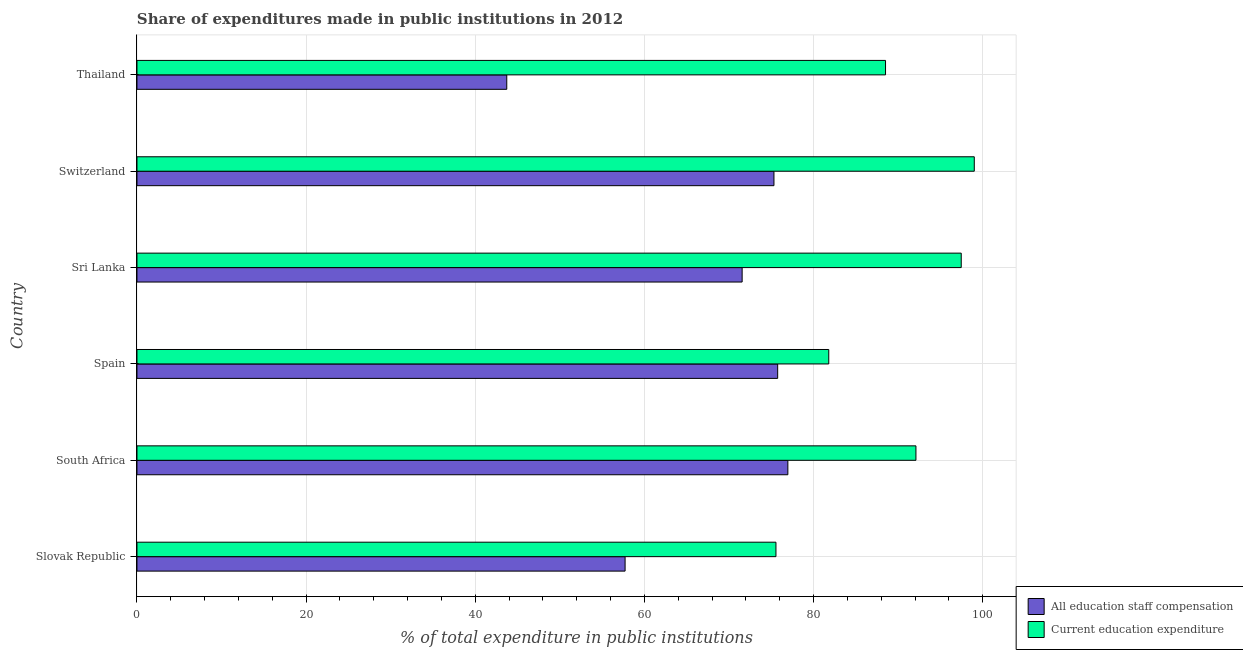How many different coloured bars are there?
Make the answer very short. 2. How many groups of bars are there?
Your answer should be compact. 6. Are the number of bars on each tick of the Y-axis equal?
Offer a very short reply. Yes. How many bars are there on the 1st tick from the bottom?
Give a very brief answer. 2. What is the label of the 6th group of bars from the top?
Give a very brief answer. Slovak Republic. What is the expenditure in staff compensation in South Africa?
Make the answer very short. 76.97. Across all countries, what is the maximum expenditure in staff compensation?
Keep it short and to the point. 76.97. Across all countries, what is the minimum expenditure in education?
Provide a succinct answer. 75.56. In which country was the expenditure in staff compensation maximum?
Give a very brief answer. South Africa. In which country was the expenditure in staff compensation minimum?
Your answer should be very brief. Thailand. What is the total expenditure in education in the graph?
Make the answer very short. 534.46. What is the difference between the expenditure in staff compensation in Slovak Republic and that in South Africa?
Make the answer very short. -19.25. What is the difference between the expenditure in staff compensation in Slovak Republic and the expenditure in education in South Africa?
Give a very brief answer. -34.39. What is the average expenditure in staff compensation per country?
Offer a very short reply. 66.84. What is the difference between the expenditure in education and expenditure in staff compensation in Slovak Republic?
Your answer should be compact. 17.84. What is the ratio of the expenditure in staff compensation in Slovak Republic to that in South Africa?
Your answer should be very brief. 0.75. What is the difference between the highest and the second highest expenditure in education?
Keep it short and to the point. 1.54. What is the difference between the highest and the lowest expenditure in education?
Your answer should be very brief. 23.45. In how many countries, is the expenditure in education greater than the average expenditure in education taken over all countries?
Your answer should be compact. 3. What does the 2nd bar from the top in Slovak Republic represents?
Provide a short and direct response. All education staff compensation. What does the 2nd bar from the bottom in Thailand represents?
Your answer should be very brief. Current education expenditure. How many bars are there?
Offer a terse response. 12. Are all the bars in the graph horizontal?
Provide a short and direct response. Yes. Does the graph contain grids?
Your response must be concise. Yes. Where does the legend appear in the graph?
Offer a terse response. Bottom right. How many legend labels are there?
Your answer should be compact. 2. How are the legend labels stacked?
Your answer should be very brief. Vertical. What is the title of the graph?
Your answer should be very brief. Share of expenditures made in public institutions in 2012. Does "By country of origin" appear as one of the legend labels in the graph?
Keep it short and to the point. No. What is the label or title of the X-axis?
Ensure brevity in your answer.  % of total expenditure in public institutions. What is the % of total expenditure in public institutions of All education staff compensation in Slovak Republic?
Ensure brevity in your answer.  57.72. What is the % of total expenditure in public institutions in Current education expenditure in Slovak Republic?
Offer a terse response. 75.56. What is the % of total expenditure in public institutions of All education staff compensation in South Africa?
Provide a short and direct response. 76.97. What is the % of total expenditure in public institutions in Current education expenditure in South Africa?
Make the answer very short. 92.11. What is the % of total expenditure in public institutions of All education staff compensation in Spain?
Offer a very short reply. 75.76. What is the % of total expenditure in public institutions in Current education expenditure in Spain?
Give a very brief answer. 81.8. What is the % of total expenditure in public institutions in All education staff compensation in Sri Lanka?
Provide a short and direct response. 71.56. What is the % of total expenditure in public institutions in Current education expenditure in Sri Lanka?
Offer a terse response. 97.47. What is the % of total expenditure in public institutions in All education staff compensation in Switzerland?
Offer a very short reply. 75.32. What is the % of total expenditure in public institutions of Current education expenditure in Switzerland?
Ensure brevity in your answer.  99.01. What is the % of total expenditure in public institutions in All education staff compensation in Thailand?
Make the answer very short. 43.73. What is the % of total expenditure in public institutions in Current education expenditure in Thailand?
Provide a succinct answer. 88.51. Across all countries, what is the maximum % of total expenditure in public institutions in All education staff compensation?
Keep it short and to the point. 76.97. Across all countries, what is the maximum % of total expenditure in public institutions in Current education expenditure?
Your answer should be compact. 99.01. Across all countries, what is the minimum % of total expenditure in public institutions in All education staff compensation?
Offer a very short reply. 43.73. Across all countries, what is the minimum % of total expenditure in public institutions of Current education expenditure?
Offer a very short reply. 75.56. What is the total % of total expenditure in public institutions in All education staff compensation in the graph?
Provide a short and direct response. 401.06. What is the total % of total expenditure in public institutions of Current education expenditure in the graph?
Your answer should be very brief. 534.46. What is the difference between the % of total expenditure in public institutions of All education staff compensation in Slovak Republic and that in South Africa?
Your answer should be compact. -19.25. What is the difference between the % of total expenditure in public institutions in Current education expenditure in Slovak Republic and that in South Africa?
Give a very brief answer. -16.55. What is the difference between the % of total expenditure in public institutions in All education staff compensation in Slovak Republic and that in Spain?
Give a very brief answer. -18.04. What is the difference between the % of total expenditure in public institutions of Current education expenditure in Slovak Republic and that in Spain?
Ensure brevity in your answer.  -6.24. What is the difference between the % of total expenditure in public institutions in All education staff compensation in Slovak Republic and that in Sri Lanka?
Provide a succinct answer. -13.84. What is the difference between the % of total expenditure in public institutions in Current education expenditure in Slovak Republic and that in Sri Lanka?
Your response must be concise. -21.91. What is the difference between the % of total expenditure in public institutions in All education staff compensation in Slovak Republic and that in Switzerland?
Offer a terse response. -17.6. What is the difference between the % of total expenditure in public institutions in Current education expenditure in Slovak Republic and that in Switzerland?
Your response must be concise. -23.45. What is the difference between the % of total expenditure in public institutions in All education staff compensation in Slovak Republic and that in Thailand?
Keep it short and to the point. 13.99. What is the difference between the % of total expenditure in public institutions in Current education expenditure in Slovak Republic and that in Thailand?
Give a very brief answer. -12.96. What is the difference between the % of total expenditure in public institutions of All education staff compensation in South Africa and that in Spain?
Provide a succinct answer. 1.21. What is the difference between the % of total expenditure in public institutions in Current education expenditure in South Africa and that in Spain?
Make the answer very short. 10.31. What is the difference between the % of total expenditure in public institutions of All education staff compensation in South Africa and that in Sri Lanka?
Provide a short and direct response. 5.41. What is the difference between the % of total expenditure in public institutions in Current education expenditure in South Africa and that in Sri Lanka?
Make the answer very short. -5.36. What is the difference between the % of total expenditure in public institutions in All education staff compensation in South Africa and that in Switzerland?
Your answer should be compact. 1.64. What is the difference between the % of total expenditure in public institutions of Current education expenditure in South Africa and that in Switzerland?
Keep it short and to the point. -6.9. What is the difference between the % of total expenditure in public institutions in All education staff compensation in South Africa and that in Thailand?
Ensure brevity in your answer.  33.24. What is the difference between the % of total expenditure in public institutions of Current education expenditure in South Africa and that in Thailand?
Offer a terse response. 3.6. What is the difference between the % of total expenditure in public institutions in All education staff compensation in Spain and that in Sri Lanka?
Provide a short and direct response. 4.2. What is the difference between the % of total expenditure in public institutions of Current education expenditure in Spain and that in Sri Lanka?
Offer a terse response. -15.66. What is the difference between the % of total expenditure in public institutions of All education staff compensation in Spain and that in Switzerland?
Offer a terse response. 0.44. What is the difference between the % of total expenditure in public institutions of Current education expenditure in Spain and that in Switzerland?
Offer a very short reply. -17.21. What is the difference between the % of total expenditure in public institutions in All education staff compensation in Spain and that in Thailand?
Offer a very short reply. 32.03. What is the difference between the % of total expenditure in public institutions of Current education expenditure in Spain and that in Thailand?
Provide a succinct answer. -6.71. What is the difference between the % of total expenditure in public institutions in All education staff compensation in Sri Lanka and that in Switzerland?
Provide a succinct answer. -3.76. What is the difference between the % of total expenditure in public institutions of Current education expenditure in Sri Lanka and that in Switzerland?
Make the answer very short. -1.54. What is the difference between the % of total expenditure in public institutions of All education staff compensation in Sri Lanka and that in Thailand?
Keep it short and to the point. 27.83. What is the difference between the % of total expenditure in public institutions in Current education expenditure in Sri Lanka and that in Thailand?
Make the answer very short. 8.95. What is the difference between the % of total expenditure in public institutions in All education staff compensation in Switzerland and that in Thailand?
Your answer should be very brief. 31.6. What is the difference between the % of total expenditure in public institutions of Current education expenditure in Switzerland and that in Thailand?
Provide a short and direct response. 10.5. What is the difference between the % of total expenditure in public institutions of All education staff compensation in Slovak Republic and the % of total expenditure in public institutions of Current education expenditure in South Africa?
Ensure brevity in your answer.  -34.39. What is the difference between the % of total expenditure in public institutions in All education staff compensation in Slovak Republic and the % of total expenditure in public institutions in Current education expenditure in Spain?
Your response must be concise. -24.08. What is the difference between the % of total expenditure in public institutions of All education staff compensation in Slovak Republic and the % of total expenditure in public institutions of Current education expenditure in Sri Lanka?
Provide a succinct answer. -39.75. What is the difference between the % of total expenditure in public institutions in All education staff compensation in Slovak Republic and the % of total expenditure in public institutions in Current education expenditure in Switzerland?
Provide a short and direct response. -41.29. What is the difference between the % of total expenditure in public institutions of All education staff compensation in Slovak Republic and the % of total expenditure in public institutions of Current education expenditure in Thailand?
Provide a succinct answer. -30.79. What is the difference between the % of total expenditure in public institutions of All education staff compensation in South Africa and the % of total expenditure in public institutions of Current education expenditure in Spain?
Make the answer very short. -4.84. What is the difference between the % of total expenditure in public institutions in All education staff compensation in South Africa and the % of total expenditure in public institutions in Current education expenditure in Sri Lanka?
Your response must be concise. -20.5. What is the difference between the % of total expenditure in public institutions in All education staff compensation in South Africa and the % of total expenditure in public institutions in Current education expenditure in Switzerland?
Make the answer very short. -22.04. What is the difference between the % of total expenditure in public institutions in All education staff compensation in South Africa and the % of total expenditure in public institutions in Current education expenditure in Thailand?
Provide a succinct answer. -11.55. What is the difference between the % of total expenditure in public institutions in All education staff compensation in Spain and the % of total expenditure in public institutions in Current education expenditure in Sri Lanka?
Your answer should be very brief. -21.71. What is the difference between the % of total expenditure in public institutions in All education staff compensation in Spain and the % of total expenditure in public institutions in Current education expenditure in Switzerland?
Your response must be concise. -23.25. What is the difference between the % of total expenditure in public institutions in All education staff compensation in Spain and the % of total expenditure in public institutions in Current education expenditure in Thailand?
Give a very brief answer. -12.75. What is the difference between the % of total expenditure in public institutions of All education staff compensation in Sri Lanka and the % of total expenditure in public institutions of Current education expenditure in Switzerland?
Provide a short and direct response. -27.45. What is the difference between the % of total expenditure in public institutions of All education staff compensation in Sri Lanka and the % of total expenditure in public institutions of Current education expenditure in Thailand?
Offer a terse response. -16.95. What is the difference between the % of total expenditure in public institutions in All education staff compensation in Switzerland and the % of total expenditure in public institutions in Current education expenditure in Thailand?
Give a very brief answer. -13.19. What is the average % of total expenditure in public institutions in All education staff compensation per country?
Your answer should be very brief. 66.84. What is the average % of total expenditure in public institutions in Current education expenditure per country?
Make the answer very short. 89.08. What is the difference between the % of total expenditure in public institutions of All education staff compensation and % of total expenditure in public institutions of Current education expenditure in Slovak Republic?
Give a very brief answer. -17.84. What is the difference between the % of total expenditure in public institutions in All education staff compensation and % of total expenditure in public institutions in Current education expenditure in South Africa?
Your response must be concise. -15.14. What is the difference between the % of total expenditure in public institutions of All education staff compensation and % of total expenditure in public institutions of Current education expenditure in Spain?
Your answer should be compact. -6.04. What is the difference between the % of total expenditure in public institutions in All education staff compensation and % of total expenditure in public institutions in Current education expenditure in Sri Lanka?
Your answer should be compact. -25.91. What is the difference between the % of total expenditure in public institutions in All education staff compensation and % of total expenditure in public institutions in Current education expenditure in Switzerland?
Give a very brief answer. -23.69. What is the difference between the % of total expenditure in public institutions of All education staff compensation and % of total expenditure in public institutions of Current education expenditure in Thailand?
Your response must be concise. -44.79. What is the ratio of the % of total expenditure in public institutions of All education staff compensation in Slovak Republic to that in South Africa?
Offer a terse response. 0.75. What is the ratio of the % of total expenditure in public institutions of Current education expenditure in Slovak Republic to that in South Africa?
Keep it short and to the point. 0.82. What is the ratio of the % of total expenditure in public institutions of All education staff compensation in Slovak Republic to that in Spain?
Your answer should be very brief. 0.76. What is the ratio of the % of total expenditure in public institutions in Current education expenditure in Slovak Republic to that in Spain?
Provide a short and direct response. 0.92. What is the ratio of the % of total expenditure in public institutions of All education staff compensation in Slovak Republic to that in Sri Lanka?
Provide a succinct answer. 0.81. What is the ratio of the % of total expenditure in public institutions of Current education expenditure in Slovak Republic to that in Sri Lanka?
Give a very brief answer. 0.78. What is the ratio of the % of total expenditure in public institutions of All education staff compensation in Slovak Republic to that in Switzerland?
Offer a terse response. 0.77. What is the ratio of the % of total expenditure in public institutions of Current education expenditure in Slovak Republic to that in Switzerland?
Your answer should be compact. 0.76. What is the ratio of the % of total expenditure in public institutions in All education staff compensation in Slovak Republic to that in Thailand?
Your response must be concise. 1.32. What is the ratio of the % of total expenditure in public institutions of Current education expenditure in Slovak Republic to that in Thailand?
Ensure brevity in your answer.  0.85. What is the ratio of the % of total expenditure in public institutions in All education staff compensation in South Africa to that in Spain?
Make the answer very short. 1.02. What is the ratio of the % of total expenditure in public institutions of Current education expenditure in South Africa to that in Spain?
Your answer should be very brief. 1.13. What is the ratio of the % of total expenditure in public institutions of All education staff compensation in South Africa to that in Sri Lanka?
Provide a short and direct response. 1.08. What is the ratio of the % of total expenditure in public institutions in Current education expenditure in South Africa to that in Sri Lanka?
Provide a succinct answer. 0.95. What is the ratio of the % of total expenditure in public institutions in All education staff compensation in South Africa to that in Switzerland?
Your response must be concise. 1.02. What is the ratio of the % of total expenditure in public institutions of Current education expenditure in South Africa to that in Switzerland?
Offer a very short reply. 0.93. What is the ratio of the % of total expenditure in public institutions in All education staff compensation in South Africa to that in Thailand?
Make the answer very short. 1.76. What is the ratio of the % of total expenditure in public institutions in Current education expenditure in South Africa to that in Thailand?
Your response must be concise. 1.04. What is the ratio of the % of total expenditure in public institutions in All education staff compensation in Spain to that in Sri Lanka?
Offer a very short reply. 1.06. What is the ratio of the % of total expenditure in public institutions in Current education expenditure in Spain to that in Sri Lanka?
Your answer should be very brief. 0.84. What is the ratio of the % of total expenditure in public institutions in All education staff compensation in Spain to that in Switzerland?
Offer a very short reply. 1.01. What is the ratio of the % of total expenditure in public institutions in Current education expenditure in Spain to that in Switzerland?
Ensure brevity in your answer.  0.83. What is the ratio of the % of total expenditure in public institutions of All education staff compensation in Spain to that in Thailand?
Offer a terse response. 1.73. What is the ratio of the % of total expenditure in public institutions in Current education expenditure in Spain to that in Thailand?
Offer a very short reply. 0.92. What is the ratio of the % of total expenditure in public institutions in All education staff compensation in Sri Lanka to that in Switzerland?
Keep it short and to the point. 0.95. What is the ratio of the % of total expenditure in public institutions in Current education expenditure in Sri Lanka to that in Switzerland?
Keep it short and to the point. 0.98. What is the ratio of the % of total expenditure in public institutions of All education staff compensation in Sri Lanka to that in Thailand?
Offer a terse response. 1.64. What is the ratio of the % of total expenditure in public institutions in Current education expenditure in Sri Lanka to that in Thailand?
Offer a terse response. 1.1. What is the ratio of the % of total expenditure in public institutions in All education staff compensation in Switzerland to that in Thailand?
Provide a short and direct response. 1.72. What is the ratio of the % of total expenditure in public institutions in Current education expenditure in Switzerland to that in Thailand?
Keep it short and to the point. 1.12. What is the difference between the highest and the second highest % of total expenditure in public institutions of All education staff compensation?
Your answer should be very brief. 1.21. What is the difference between the highest and the second highest % of total expenditure in public institutions in Current education expenditure?
Offer a very short reply. 1.54. What is the difference between the highest and the lowest % of total expenditure in public institutions in All education staff compensation?
Provide a short and direct response. 33.24. What is the difference between the highest and the lowest % of total expenditure in public institutions in Current education expenditure?
Ensure brevity in your answer.  23.45. 